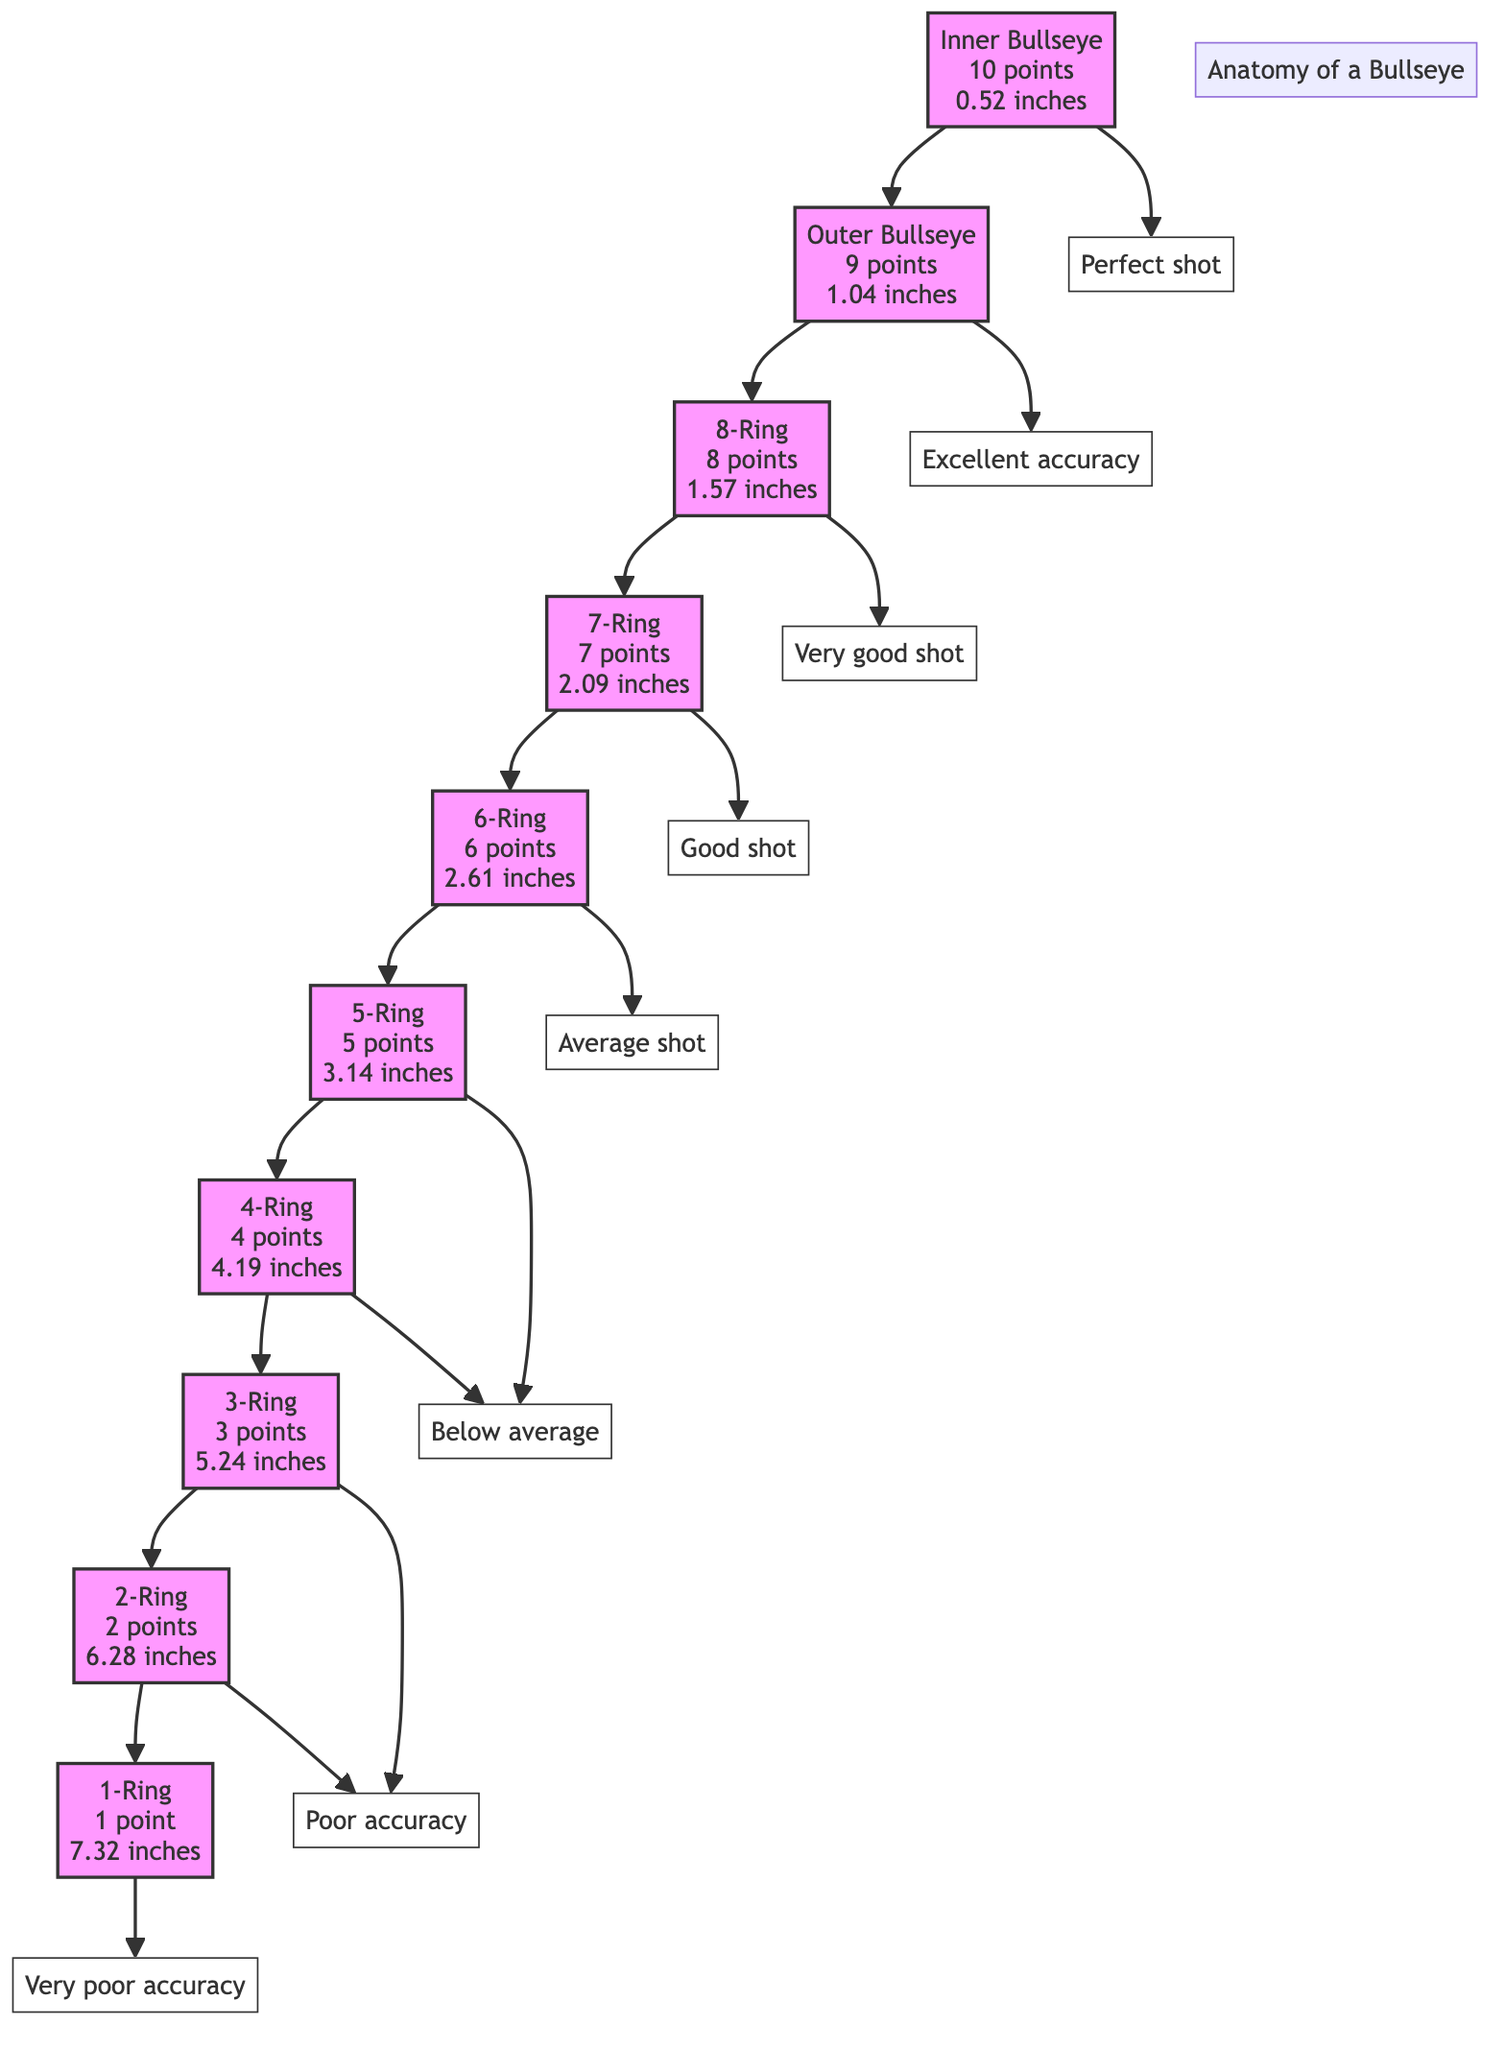What is the point value for the Inner Bullseye? The Inner Bullseye is labeled with "10 points" in the diagram. Therefore, the answer can be found directly by looking at the first node in the flow, which represents the Inner Bullseye.
Answer: 10 points What is the diameter of the 7-Ring? The 7-Ring is shown as having a diameter of "2.09 inches." This information is stated in the node description for the 7-Ring.
Answer: 2.09 inches How many scoring zones are illustrated in the diagram? The diagram contains scoring zones from the Inner Bullseye down to the 1-Ring, totaling 10 scoring zones, one for each ring. This can be counted from the nodes A through J.
Answer: 10 What point value corresponds to a shot in the 4-Ring? The 4-Ring is labeled with "4 points" in the diagram. This is found by identifying the node that represents the 4-Ring.
Answer: 4 points What is the significance of a shot in the Outer Bullseye? The Outer Bullseye is noted for "Excellent accuracy" in the diagram, which means that hitting this area is recognized positively. This is connected to node B.
Answer: Excellent accuracy If a shooter hits the 3-Ring, what scoring implication does it have? Shooting in the 3-Ring corresponds to "3 points" and is categorized under "Poor accuracy." This is indicated by connections from node H to both the points and accuracy descriptions.
Answer: Poor accuracy Which scoring zones have the same point value? The 5-Ring and 4-Ring both correspond to the same category of "Below average," despite differing point values. This is determined by examining the relational values linked to nodes F and G.
Answer: Below average What is the highest point value zone in the diagram? The highest point value zone is the Inner Bullseye which offers "10 points." This can be found at the top of the scoring zones flow.
Answer: Inner Bullseye What does a shot in the 1-Ring indicate about accuracy? A shot in the 1-Ring has a scoring implication of "Very poor accuracy," as shown in the diagram through the connection from node J.
Answer: Very poor accuracy 